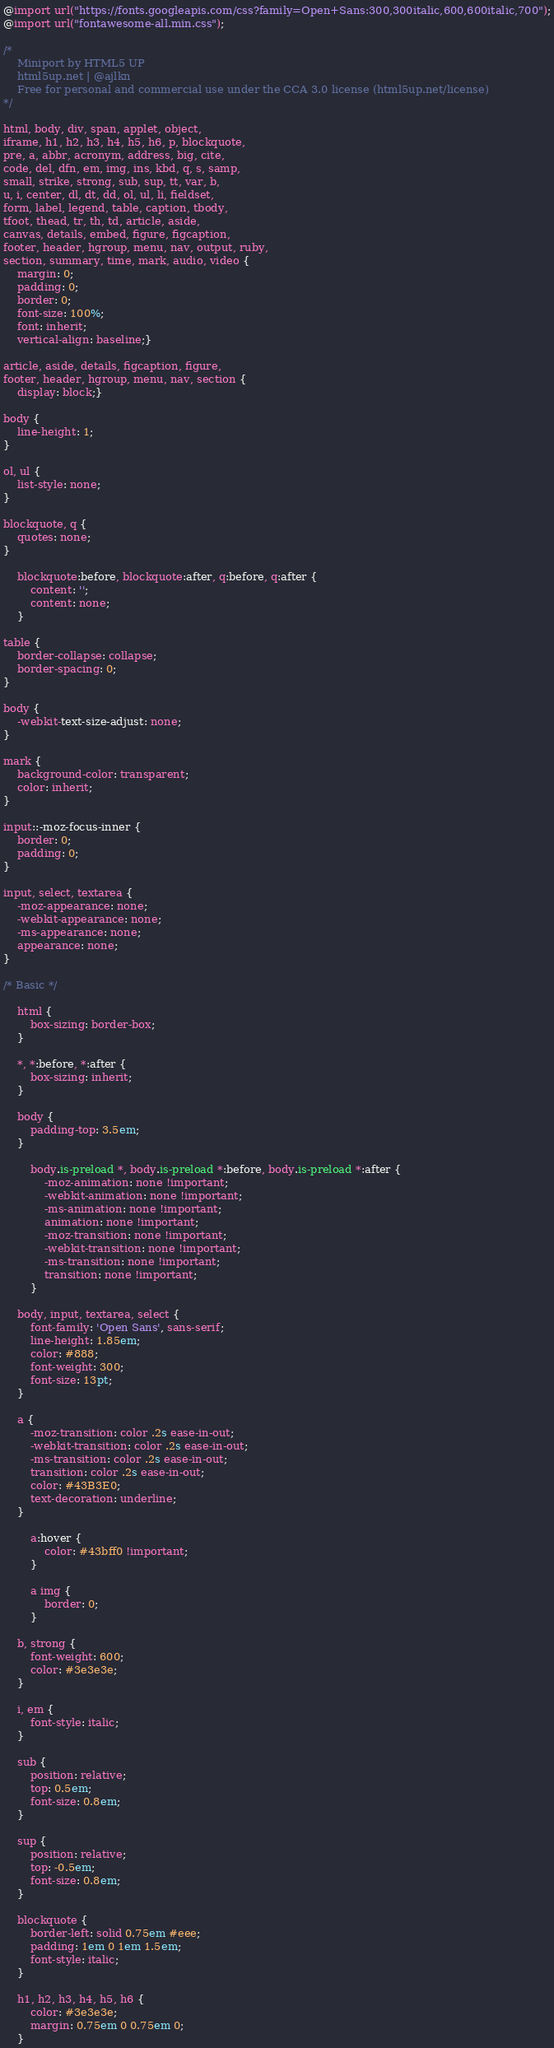<code> <loc_0><loc_0><loc_500><loc_500><_CSS_>@import url("https://fonts.googleapis.com/css?family=Open+Sans:300,300italic,600,600italic,700");
@import url("fontawesome-all.min.css");

/*
	Miniport by HTML5 UP
	html5up.net | @ajlkn
	Free for personal and commercial use under the CCA 3.0 license (html5up.net/license)
*/

html, body, div, span, applet, object,
iframe, h1, h2, h3, h4, h5, h6, p, blockquote,
pre, a, abbr, acronym, address, big, cite,
code, del, dfn, em, img, ins, kbd, q, s, samp,
small, strike, strong, sub, sup, tt, var, b,
u, i, center, dl, dt, dd, ol, ul, li, fieldset,
form, label, legend, table, caption, tbody,
tfoot, thead, tr, th, td, article, aside,
canvas, details, embed, figure, figcaption,
footer, header, hgroup, menu, nav, output, ruby,
section, summary, time, mark, audio, video {
	margin: 0;
	padding: 0;
	border: 0;
	font-size: 100%;
	font: inherit;
	vertical-align: baseline;}

article, aside, details, figcaption, figure,
footer, header, hgroup, menu, nav, section {
	display: block;}

body {
	line-height: 1;
}

ol, ul {
	list-style: none;
}

blockquote, q {
	quotes: none;
}

	blockquote:before, blockquote:after, q:before, q:after {
		content: '';
		content: none;
	}

table {
	border-collapse: collapse;
	border-spacing: 0;
}

body {
	-webkit-text-size-adjust: none;
}

mark {
	background-color: transparent;
	color: inherit;
}

input::-moz-focus-inner {
	border: 0;
	padding: 0;
}

input, select, textarea {
	-moz-appearance: none;
	-webkit-appearance: none;
	-ms-appearance: none;
	appearance: none;
}

/* Basic */

	html {
		box-sizing: border-box;
	}

	*, *:before, *:after {
		box-sizing: inherit;
	}

	body {
		padding-top: 3.5em;
	}

		body.is-preload *, body.is-preload *:before, body.is-preload *:after {
			-moz-animation: none !important;
			-webkit-animation: none !important;
			-ms-animation: none !important;
			animation: none !important;
			-moz-transition: none !important;
			-webkit-transition: none !important;
			-ms-transition: none !important;
			transition: none !important;
		}

	body, input, textarea, select {
		font-family: 'Open Sans', sans-serif;
		line-height: 1.85em;
		color: #888;
		font-weight: 300;
		font-size: 13pt;
	}

	a {
		-moz-transition: color .2s ease-in-out;
		-webkit-transition: color .2s ease-in-out;
		-ms-transition: color .2s ease-in-out;
		transition: color .2s ease-in-out;
		color: #43B3E0;
		text-decoration: underline;
	}

		a:hover {
			color: #43bff0 !important;
		}

		a img {
			border: 0;
		}

	b, strong {
		font-weight: 600;
		color: #3e3e3e;
	}

	i, em {
		font-style: italic;
	}

	sub {
		position: relative;
		top: 0.5em;
		font-size: 0.8em;
	}

	sup {
		position: relative;
		top: -0.5em;
		font-size: 0.8em;
	}

	blockquote {
		border-left: solid 0.75em #eee;
		padding: 1em 0 1em 1.5em;
		font-style: italic;
	}

	h1, h2, h3, h4, h5, h6 {
		color: #3e3e3e;
		margin: 0.75em 0 0.75em 0;
	}
</code> 